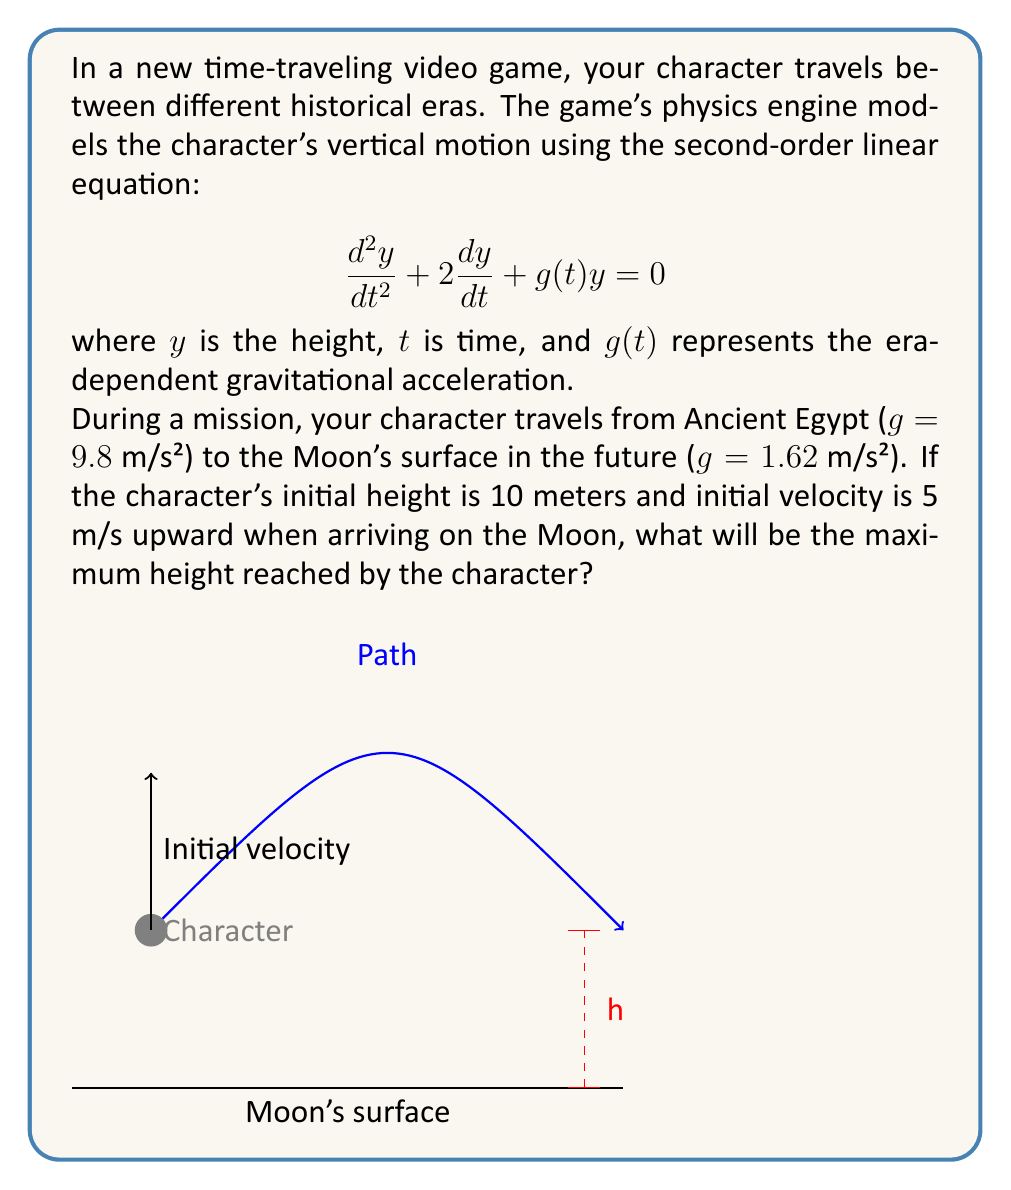Give your solution to this math problem. Let's solve this problem step by step:

1) The general solution for this type of second-order linear equation is:

   $$y(t) = (A + Bt)e^{-t}$$

   where $A$ and $B$ are constants determined by initial conditions.

2) Given the initial conditions:
   $y(0) = 10$ (initial height)
   $y'(0) = 5$ (initial velocity upward)

3) Let's find $A$ and $B$:
   $y(0) = A = 10$
   $y'(t) = (-A - Bt + B)e^{-t}$
   $y'(0) = -A + B = 5$
   $-10 + B = 5$
   $B = 15$

4) So, our solution is:
   $$y(t) = (10 + 15t)e^{-t}$$

5) To find the maximum height, we need to find where $y'(t) = 0$:
   $y'(t) = (-10 - 15t + 15)e^{-t} = 0$
   $-10 - 15t + 15 = 0$
   $-15t = -5$
   $t = \frac{1}{3}$

6) The maximum height is reached at $t = \frac{1}{3}$. Let's calculate it:
   $$y(\frac{1}{3}) = (10 + 15(\frac{1}{3}))e^{-\frac{1}{3}}$$
   $$= 15e^{-\frac{1}{3}} \approx 10.75$$

Therefore, the maximum height reached by the character on the Moon is approximately 10.75 meters.
Answer: 10.75 meters 